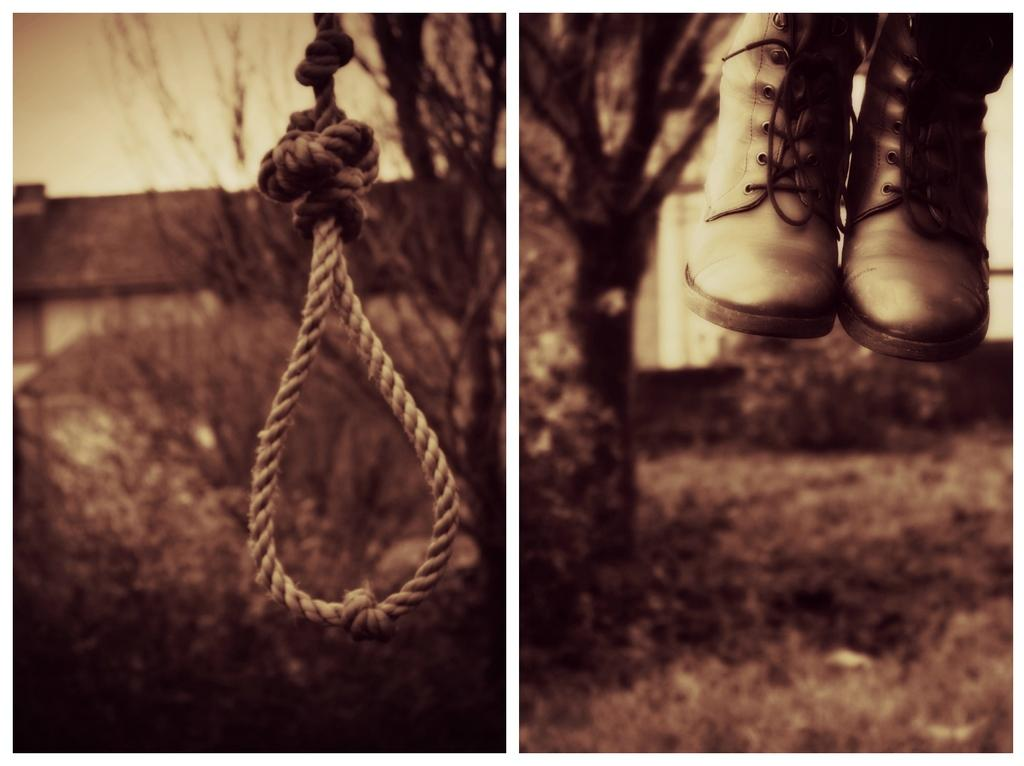What is present in the first image? The first image contains a rope, a building, and a tree. Can you describe the setting of the first image? The setting of the first image includes a building and a tree. What is the main feature of the second image? The main feature of the second image is grassy land. Are there any trees in the second image? Yes, there is a tree in the second image. What type of cloth is draped over the tree in the first image? There is no cloth present in either image, let alone draped over a tree. 